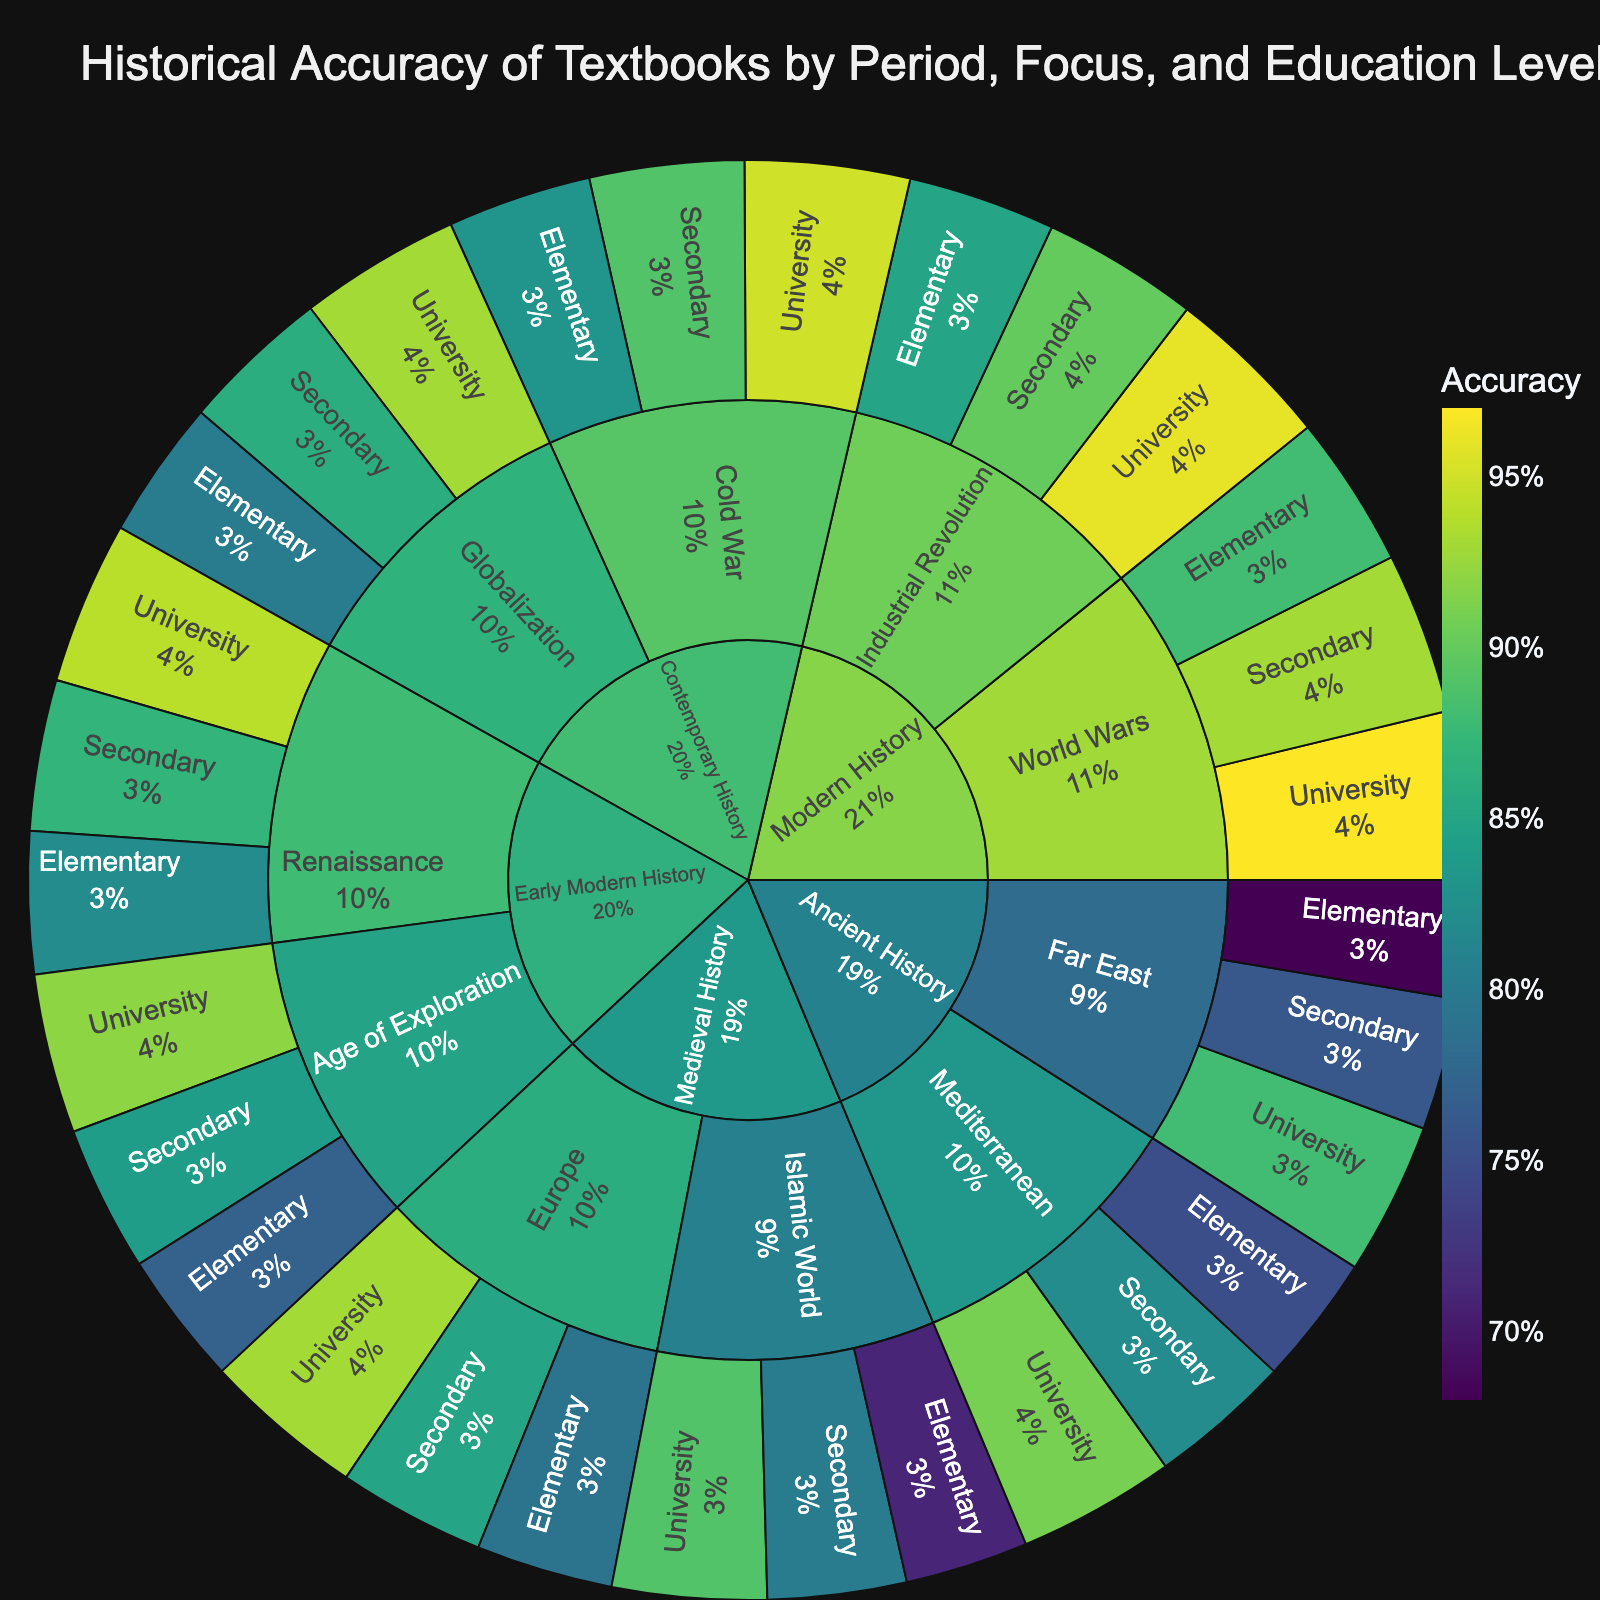What is the title of the sunburst plot? The title of the plot is generally found at the top of the figure, indicating the main subject of the visual representation. For this figure, the title is "Historical Accuracy of Textbooks by Period, Focus, and Education Level".
Answer: Historical Accuracy of Textbooks by Period, Focus, and Education Level Which category has the highest overall historical accuracy in university-level textbooks? In the figure, categories such as "Ancient History", "Medieval History", "Early Modern History", "Modern History", and "Contemporary History" are compared. Modern History University-level textbooks have the highest accuracy with values of 0.96 and 0.97 for "Industrial Revolution" and "World Wars" respectively.
Answer: Modern History Among the subcategories within "Medieval History," which has a higher average historical accuracy across all education levels: "Europe" or "Islamic World"? The average historical accuracy for "Europe" is calculated from the values 0.79 (Elementary), 0.85 (Secondary), and 0.93 (University), leading to (0.79 + 0.85 + 0.93)/3 = 0.8567. For "Islamic World," the values are 0.71 (Elementary), 0.80 (Secondary), and 0.89 (University), leading to (0.71 + 0.80 + 0.89)/3 = 0.80.
Answer: Europe What is the accuracy value for "Cold War" textbooks at the secondary education level? The figure has detailed data by category, subcategory, and subsubcategory. For "Cold War" under "Contemporary History" at the "Secondary" level, the depicted accuracy value is 0.89.
Answer: 0.89 Comparing Elementary-level historical accuracy, which subcategory in "Early Modern History" has a higher accuracy: "Renaissance" or "Age of Exploration"? Within "Early Modern History," the accuracy values for Elementary are 0.82 for "Renaissance" and 0.77 for "Age of Exploration". By comparing these values, "Renaissance" has a higher accuracy.
Answer: Renaissance By how much does the University-level accuracy of "Ancient History" in the "Far East" exceed the Elementary-level accuracy in the same subcategory? The University-level accuracy for "Ancient History" in the "Far East" is 0.88 and the Elementary-level accuracy is 0.68. The difference is given by 0.88 - 0.68 = 0.20.
Answer: 0.20 Between "World Wars" and "Cold War," which subcategory within "Modern History" has higher elementary-level accuracy? In the figure, under "Modern History" for Elementary education level, "World Wars" has an accuracy of 0.88 while "Cold War" has an accuracy of 0.83. Hence, "World Wars" has a higher accuracy.
Answer: World Wars Summing up the accuracy values for the "Industrial Revolution" across all education levels, what is the total accuracy? The values for "Industrial Revolution" are 0.85 (Elementary), 0.90 (Secondary), and 0.96 (University). The total is calculated as 0.85 + 0.90 + 0.96 = 2.71.
Answer: 2.71 